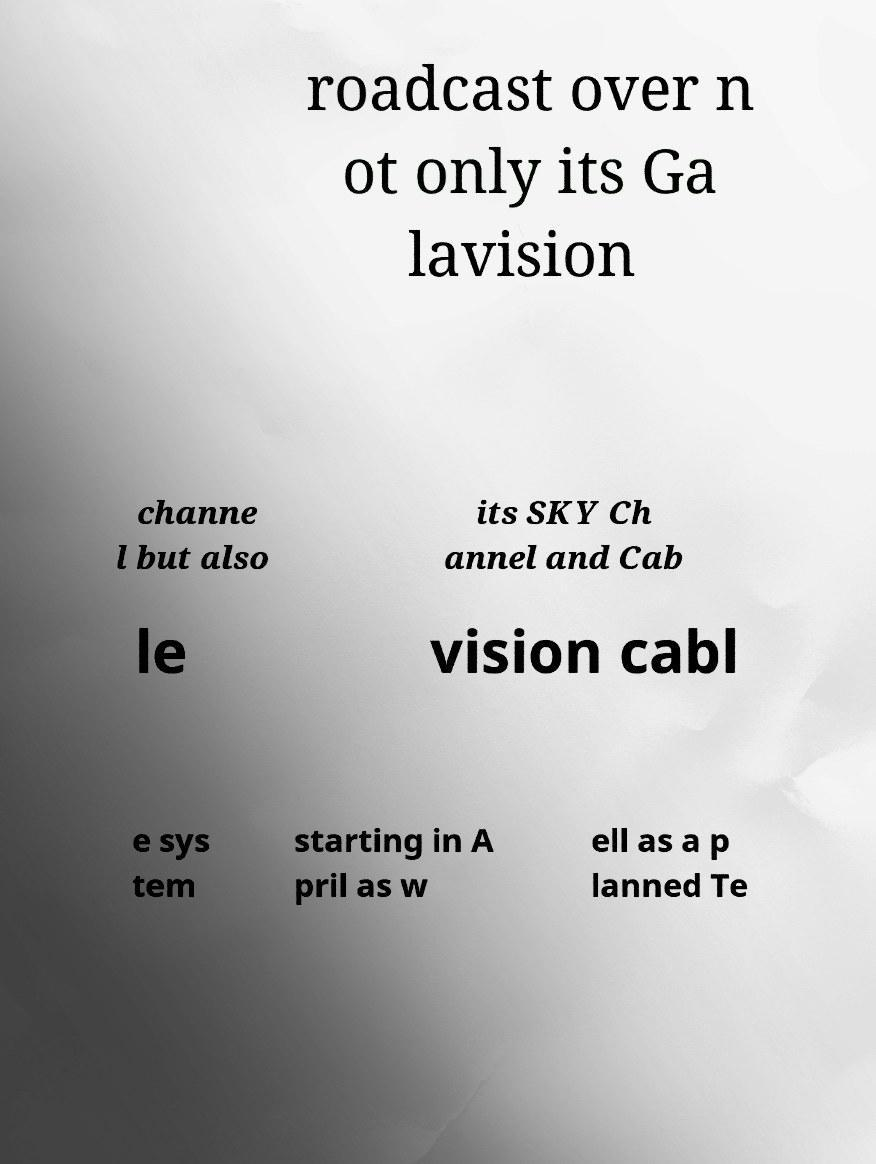Could you assist in decoding the text presented in this image and type it out clearly? roadcast over n ot only its Ga lavision channe l but also its SKY Ch annel and Cab le vision cabl e sys tem starting in A pril as w ell as a p lanned Te 